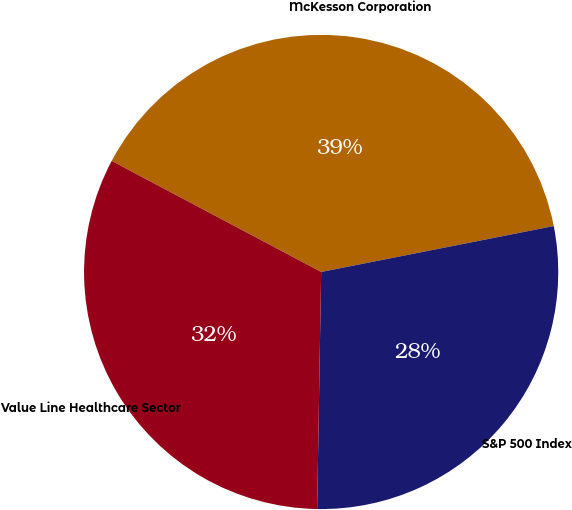<chart> <loc_0><loc_0><loc_500><loc_500><pie_chart><fcel>McKesson Corporation<fcel>S&P 500 Index<fcel>Value Line Healthcare Sector<nl><fcel>39.14%<fcel>28.37%<fcel>32.49%<nl></chart> 